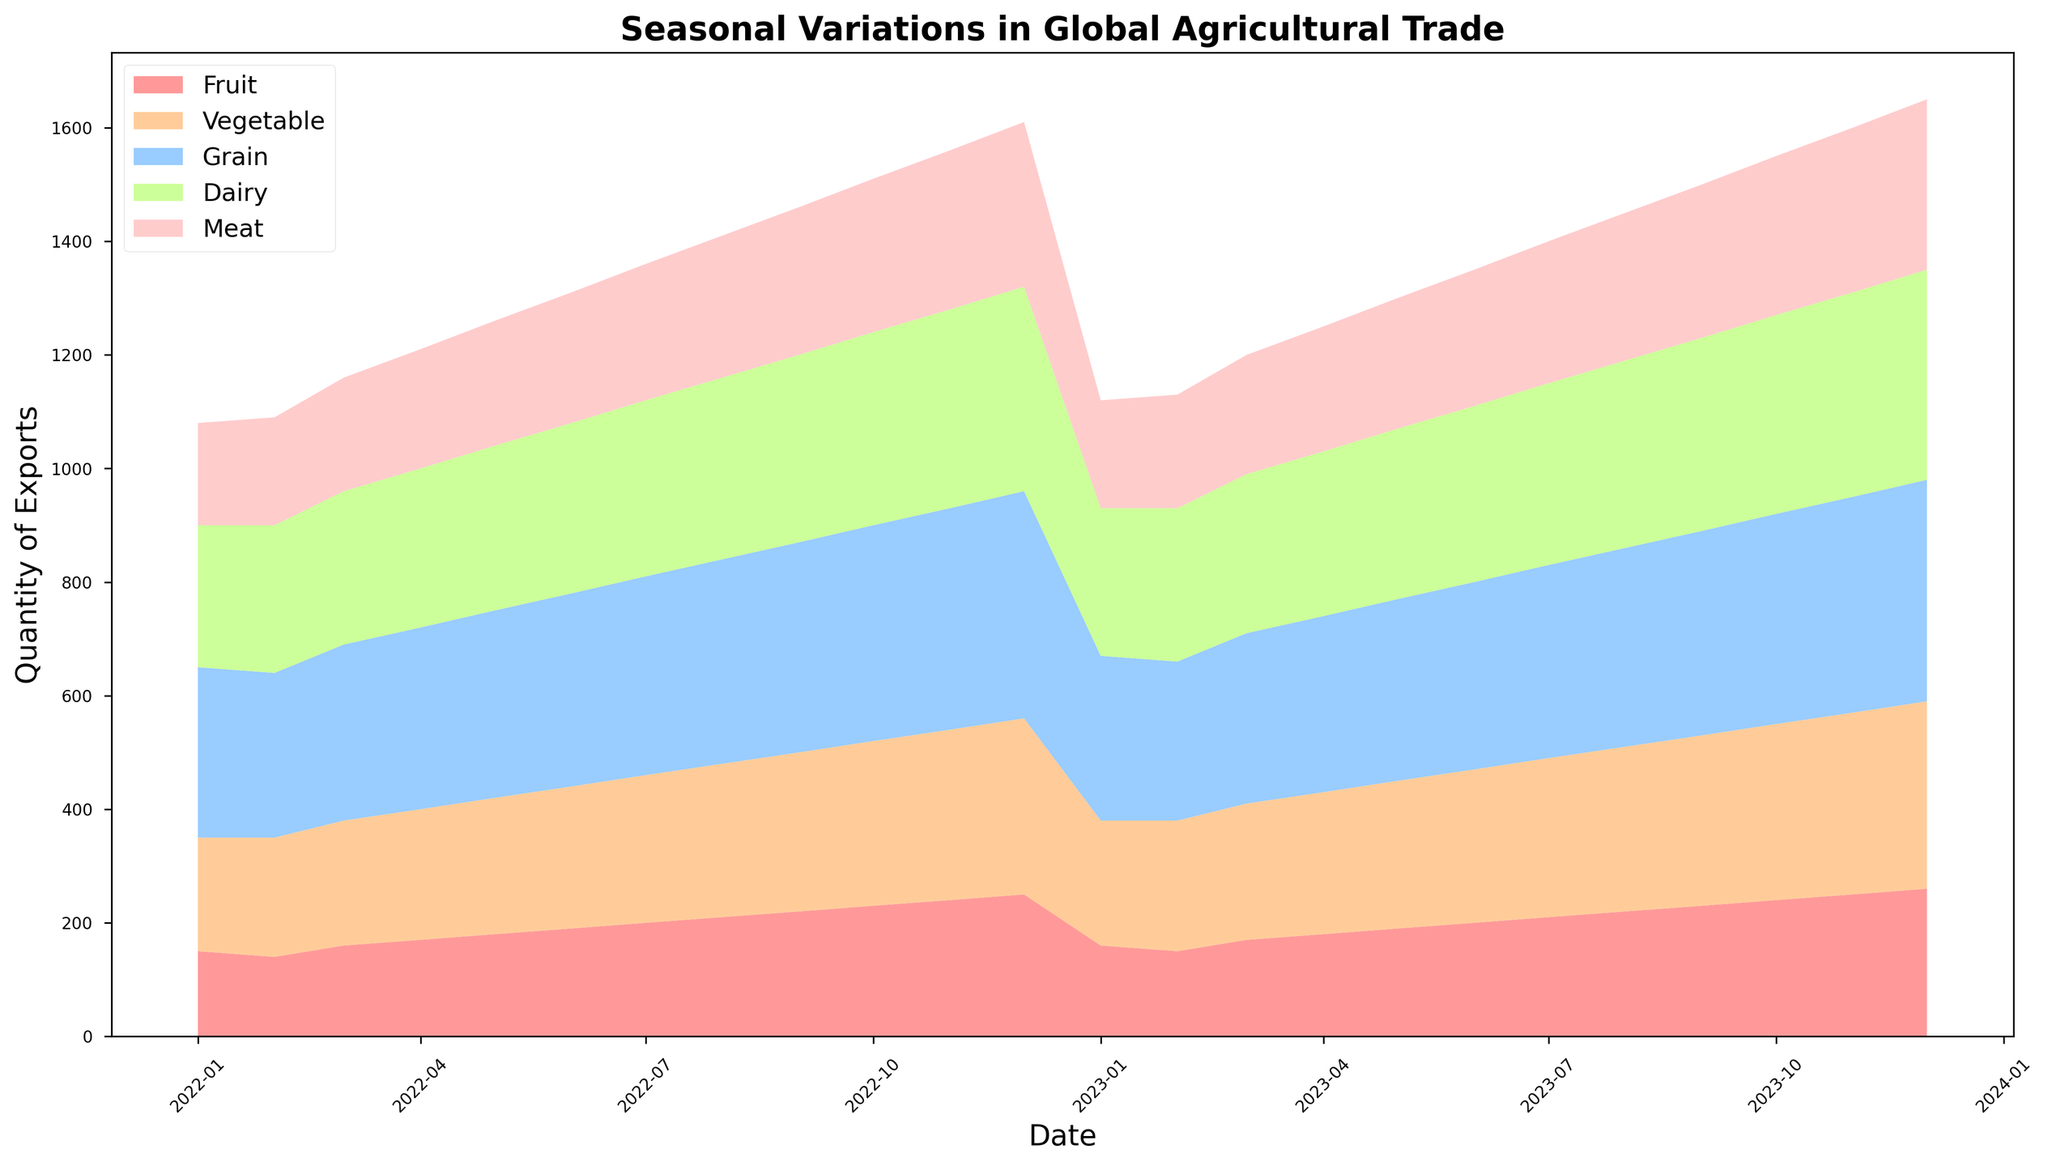Which month in 2022 had the highest total export quantity? Sum the export quantities of all categories for each month and compare them. The highest total is in December 2022 with FruitExports (250) + VegetableExports (310) + GrainExports (400) + DairyExports (360) + MeatExports (290) = 1610.
Answer: December Between April 2023 and August 2023, which category saw a consistent increase in export quantity each month? Check for a consistent increase in each category month-by-month between April and August. FruitExports increase from 180 to 220, meeting the criteria.
Answer: FruitExports Does the export quantity of DairyExports ever exceed that of MeatExports? If so, when? Compare DairyExports and MeatExports month-by-month across the entire data range. DairyExports exceed MeatExports in all months.
Answer: Every month What is the average export quantity of GrainExports for the year 2022? Sum all GrainExports for 2022 and divide by 12. (300+290+310+320+330+340+350+360+370+380+390+400)/12 = 344.17
Answer: 344.17 How does the total export quantity of Fruits in December 2022 compare to December 2023? Compare FruitExports in December 2022 and December 2023. 2022 has 250 and 2023 has 260. 2023 is 10 units higher.
Answer: 2023 is higher Which category shows the least variation in export quantity over the observed period? Inspect the visual plot to assess variability; least variation is where the area seems most stable. MeatExports show the least variation.
Answer: MeatExports By how much did the total January export quantity change from 2022 to 2023? Calculate total exports for January in 2022 (180+200+300+250+180=1110) and 2023 (160+220+290+260+190=1120). The change is 1120-1110=10 units.
Answer: Increase by 10 units If the export quantity for each category in February 2023 increased by 20% from February 2022, what would be the revised figures? Calculate 120% of each February 2022 value: Fruits: 140 * 1.2 = 168, Vegetables: 210 * 1.2 = 252, Grains: 290 * 1.2 = 348, Dairy: 260 * 1.2 = 312, Meat: 190 * 1.2 = 228.
Answer: Fruits: 168, Vegetables: 252, Grains: 348, Dairy: 312, Meat: 228 In which month and year did VegetableExports first reach 300 units? Review the graph to see the point where VegetableExports reaches 300 units. It first hits 300 units in November 2022.
Answer: November 2022 